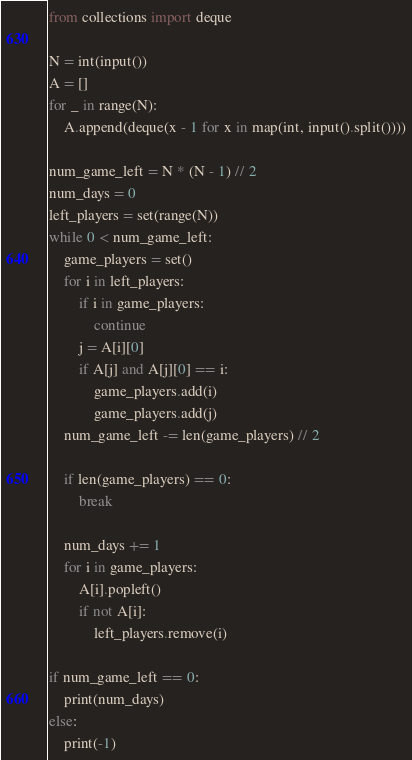Convert code to text. <code><loc_0><loc_0><loc_500><loc_500><_Python_>from collections import deque

N = int(input())
A = []
for _ in range(N):
    A.append(deque(x - 1 for x in map(int, input().split())))

num_game_left = N * (N - 1) // 2
num_days = 0
left_players = set(range(N))
while 0 < num_game_left:
    game_players = set()
    for i in left_players:
        if i in game_players:
            continue
        j = A[i][0]
        if A[j] and A[j][0] == i:
            game_players.add(i)
            game_players.add(j)
    num_game_left -= len(game_players) // 2

    if len(game_players) == 0:
        break

    num_days += 1
    for i in game_players:
        A[i].popleft()
        if not A[i]:
            left_players.remove(i)

if num_game_left == 0:
    print(num_days)
else:
    print(-1)</code> 